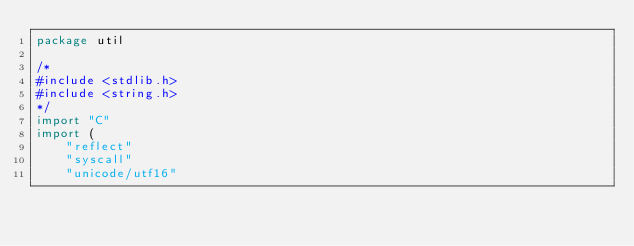<code> <loc_0><loc_0><loc_500><loc_500><_Go_>package util

/*
#include <stdlib.h>
#include <string.h>
*/
import "C"
import (
	"reflect"
	"syscall"
	"unicode/utf16"</code> 